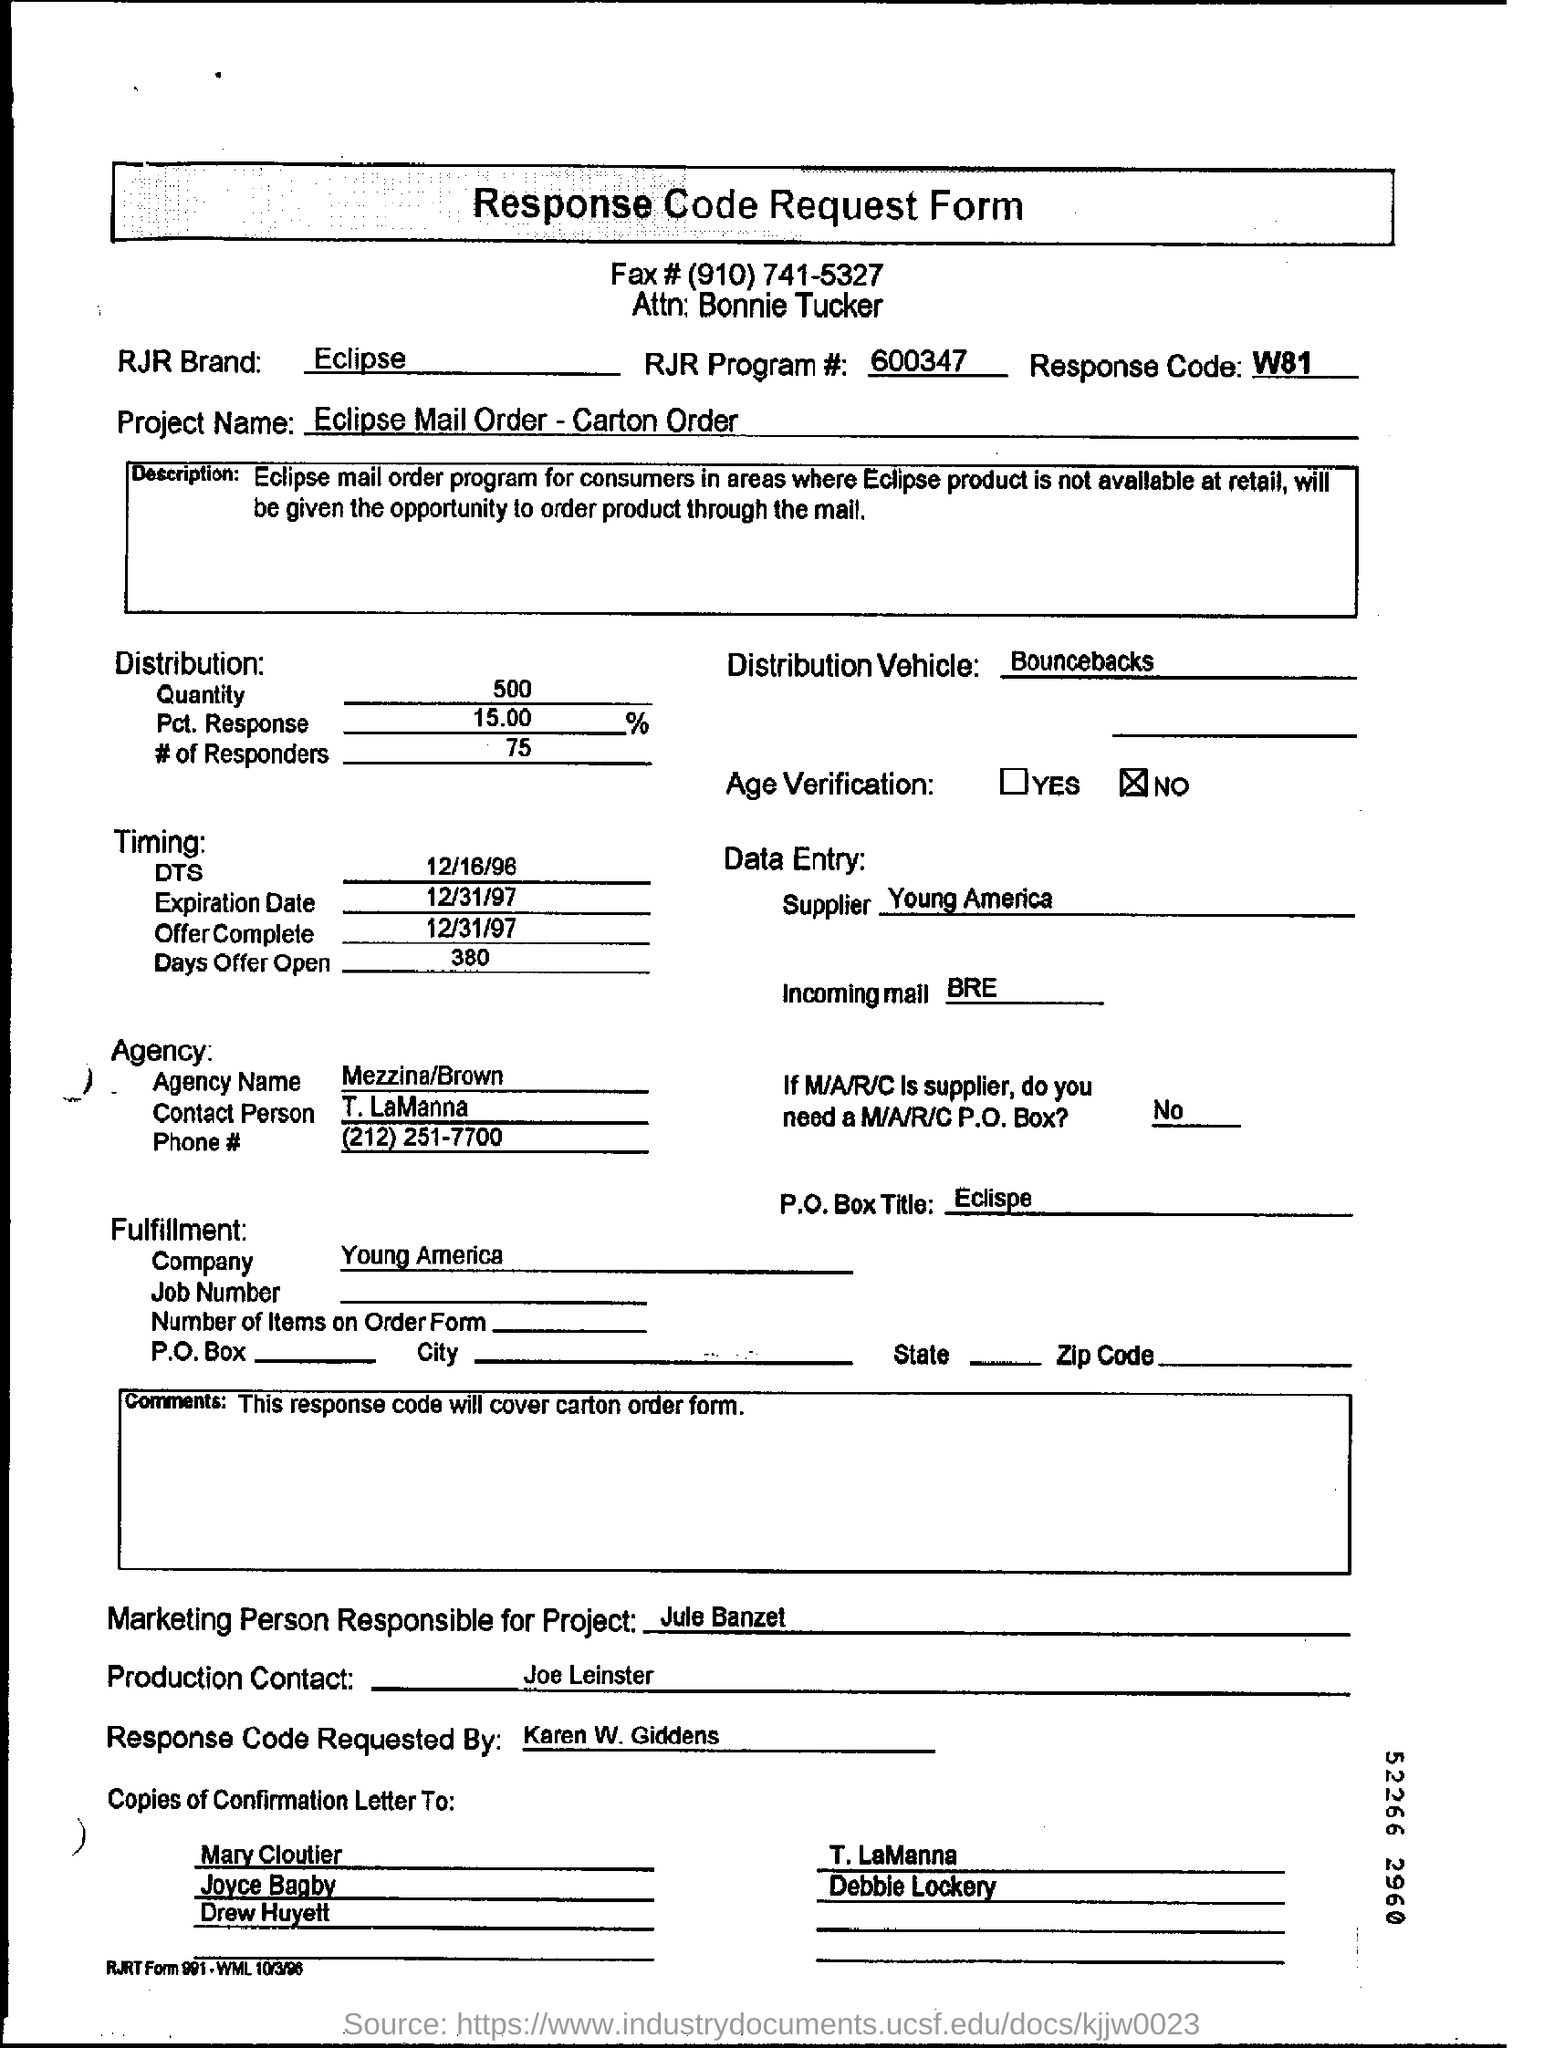What is the response code mentioned in the document?
Offer a terse response. W81. What is the Expiration date mentioned in the request form?
Offer a very short reply. 12/31/97. Who is the  Agency Contact person as per the document?
Your answer should be very brief. T. LaManna. What is the distribution quantity given in the request form?
Provide a short and direct response. 500. What is the project name mentioned in the request form?
Keep it short and to the point. Eclipse Mail Order - Carton Order. Who requested the Response Code?
Provide a succinct answer. Karen W. Giddens. 